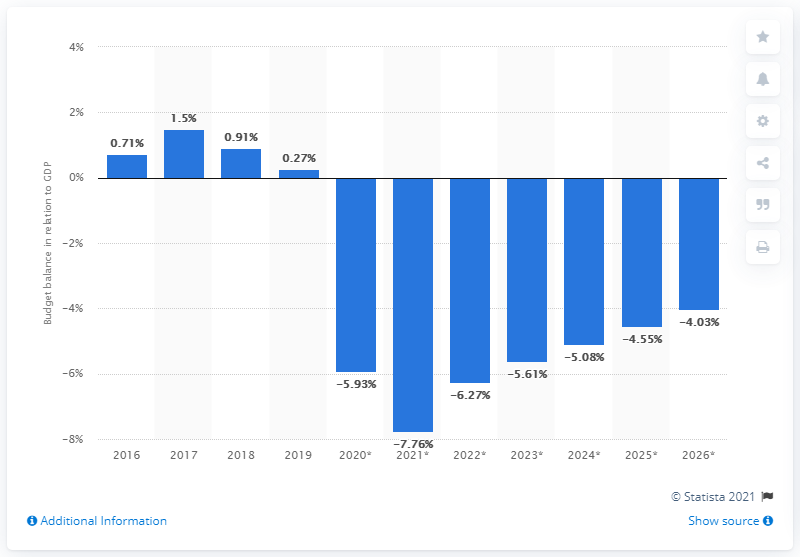List a handful of essential elements in this visual. The budget surplus in 2019 accounted for 0.27% of the country's gross domestic product (GDP). 